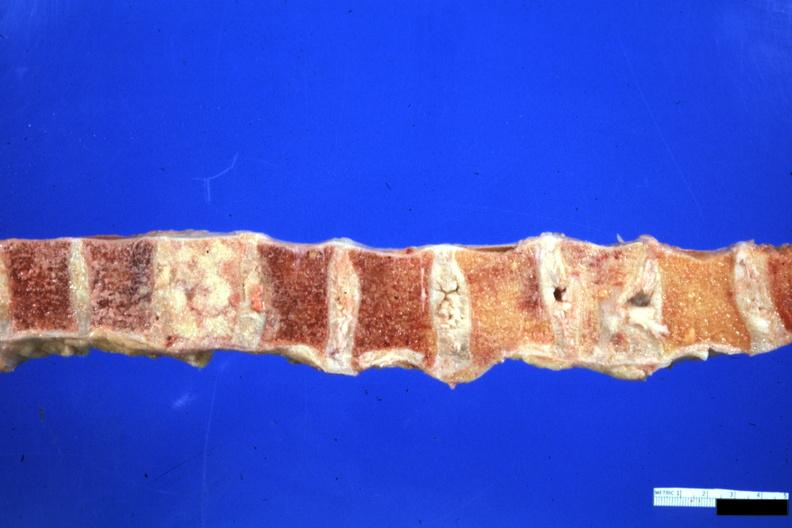s joints present?
Answer the question using a single word or phrase. Yes 